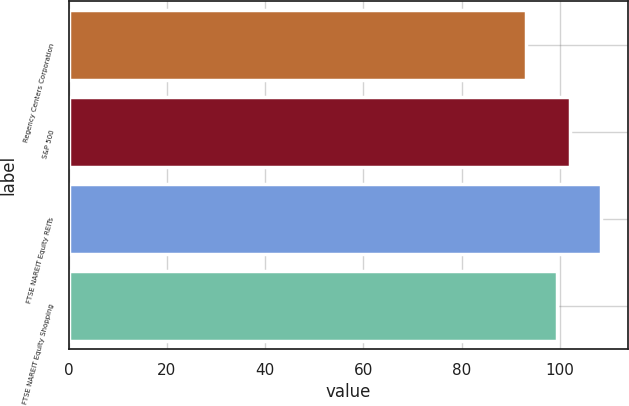<chart> <loc_0><loc_0><loc_500><loc_500><bar_chart><fcel>Regency Centers Corporation<fcel>S&P 500<fcel>FTSE NAREIT Equity REITs<fcel>FTSE NAREIT Equity Shopping<nl><fcel>93.15<fcel>102.11<fcel>108.29<fcel>99.27<nl></chart> 